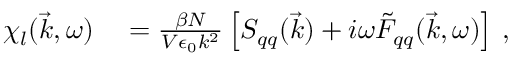Convert formula to latex. <formula><loc_0><loc_0><loc_500><loc_500>\begin{array} { r l } { \chi _ { l } ( \vec { k } , \omega ) } & = \frac { \beta N } { V \epsilon _ { 0 } k ^ { 2 } } \left [ S _ { q q } ( \vec { k } ) + i \omega \tilde { F } _ { q q } ( \vec { k } , \omega ) \right ] \, , } \end{array}</formula> 